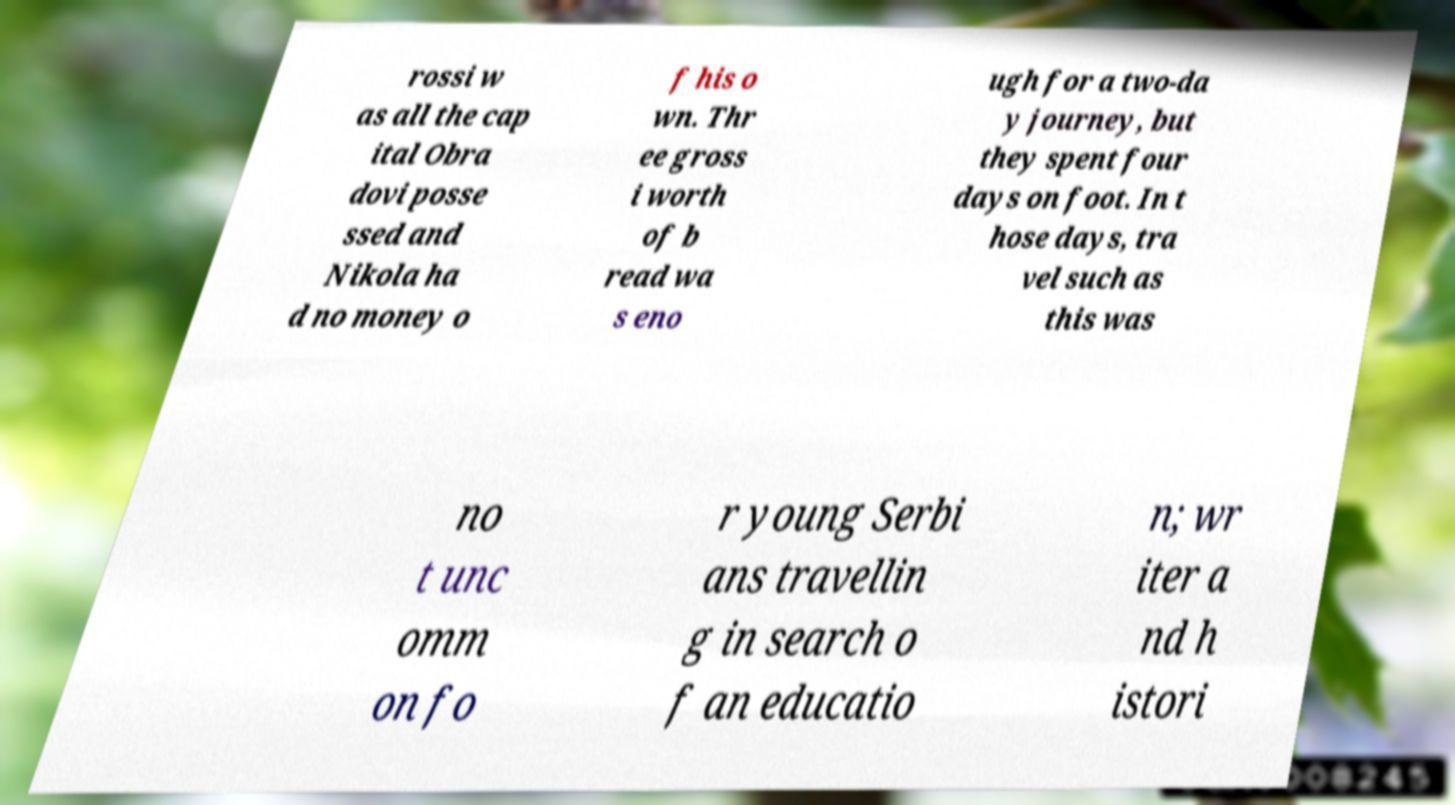There's text embedded in this image that I need extracted. Can you transcribe it verbatim? rossi w as all the cap ital Obra dovi posse ssed and Nikola ha d no money o f his o wn. Thr ee gross i worth of b read wa s eno ugh for a two-da y journey, but they spent four days on foot. In t hose days, tra vel such as this was no t unc omm on fo r young Serbi ans travellin g in search o f an educatio n; wr iter a nd h istori 